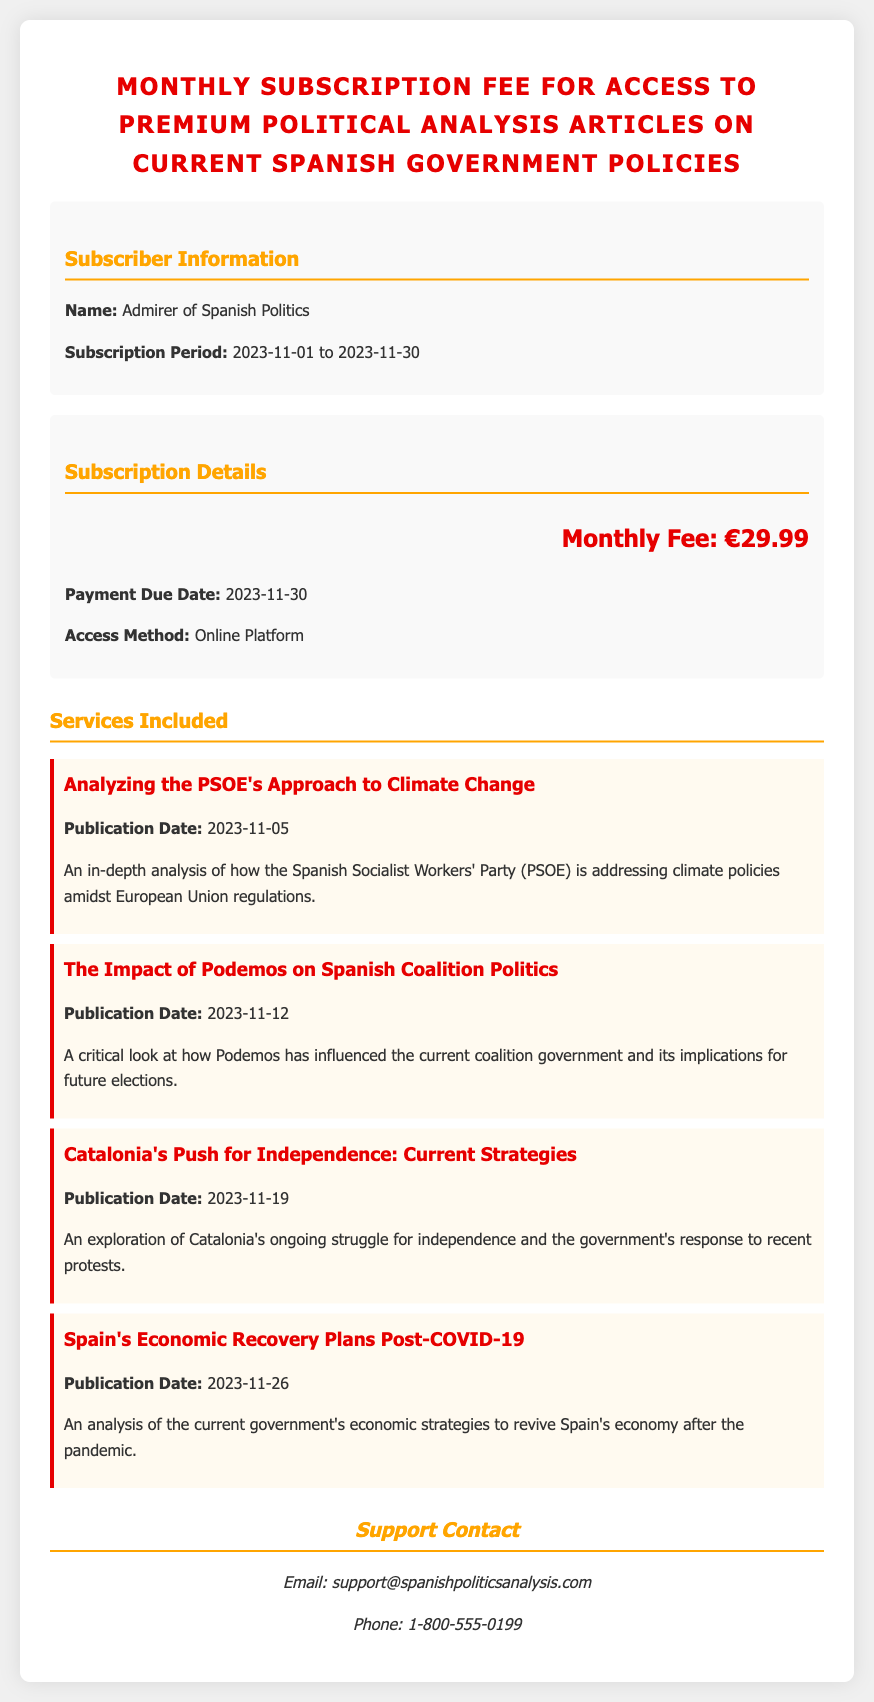What is the monthly fee for the subscription? The subscription fee is specified in the document as €29.99.
Answer: €29.99 What is the subscriber's name? The document provides the subscriber's name under "Subscriber Information," which is "Admirer of Spanish Politics."
Answer: Admirer of Spanish Politics What is the payment due date? The document states the payment due date for the subscription as "2023-11-30."
Answer: 2023-11-30 What publication date is listed for the article on Catalonia's independence? The date for this article is included in the document, which specifies it as "2023-11-19."
Answer: 2023-11-19 How long is the subscription period? The subscription period is detailed in the document, running from "2023-11-01" to "2023-11-30."
Answer: 2023-11-01 to 2023-11-30 What type of content is provided in the analysis subscription? The document lists the content type as "Premium Political Analysis Articles."
Answer: Premium Political Analysis Articles What is the last article publication date? The last article listed in the document is about "Spain's Economic Recovery Plans Post-COVID-19," with a publication date of "2023-11-26."
Answer: 2023-11-26 What is the access method for the subscription? The document outlines that access is provided through an "Online Platform."
Answer: Online Platform What article discusses the PSOE's approach? The title of this article is provided as "Analyzing the PSOE's Approach to Climate Change."
Answer: Analyzing the PSOE's Approach to Climate Change 